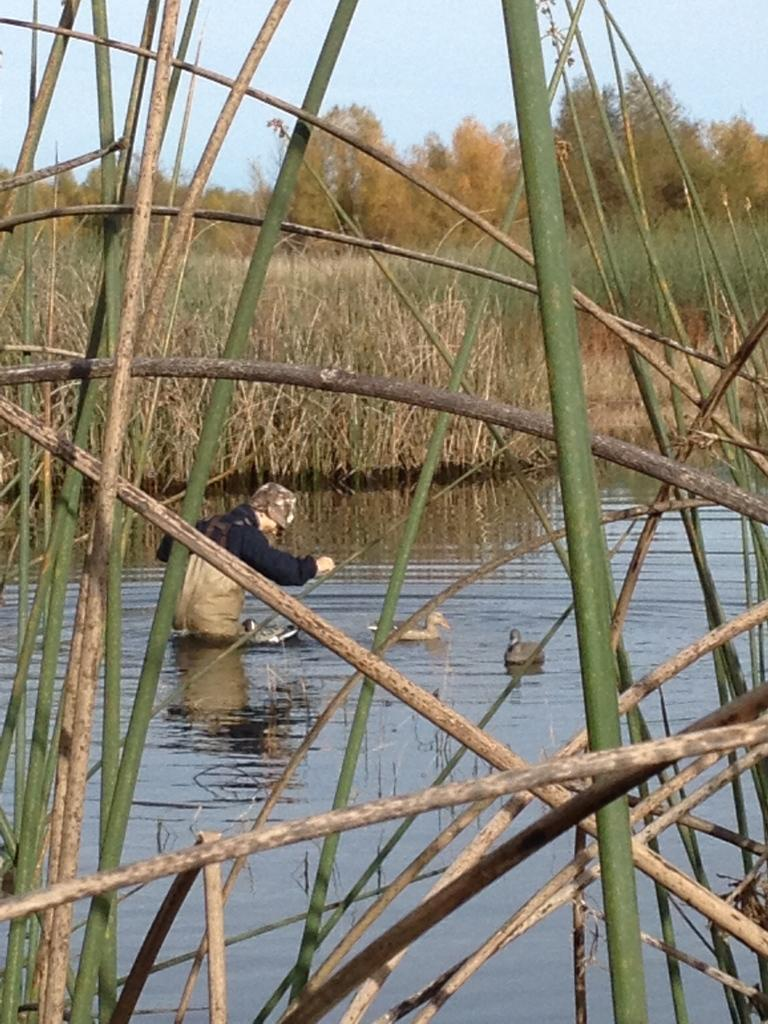What is the person in the image doing? There is a person standing in the water in the image. What animals can be seen in the water? Ducks are swimming in the water in the image. What type of vegetation is visible in the background? There is grass visible in the background of the image. What else can be seen in the background? Trees and the sky are visible in the background of the image. Where is the sink located in the image? There is no sink present in the image. How many cubs are visible in the image? There are no cubs present in the image. 